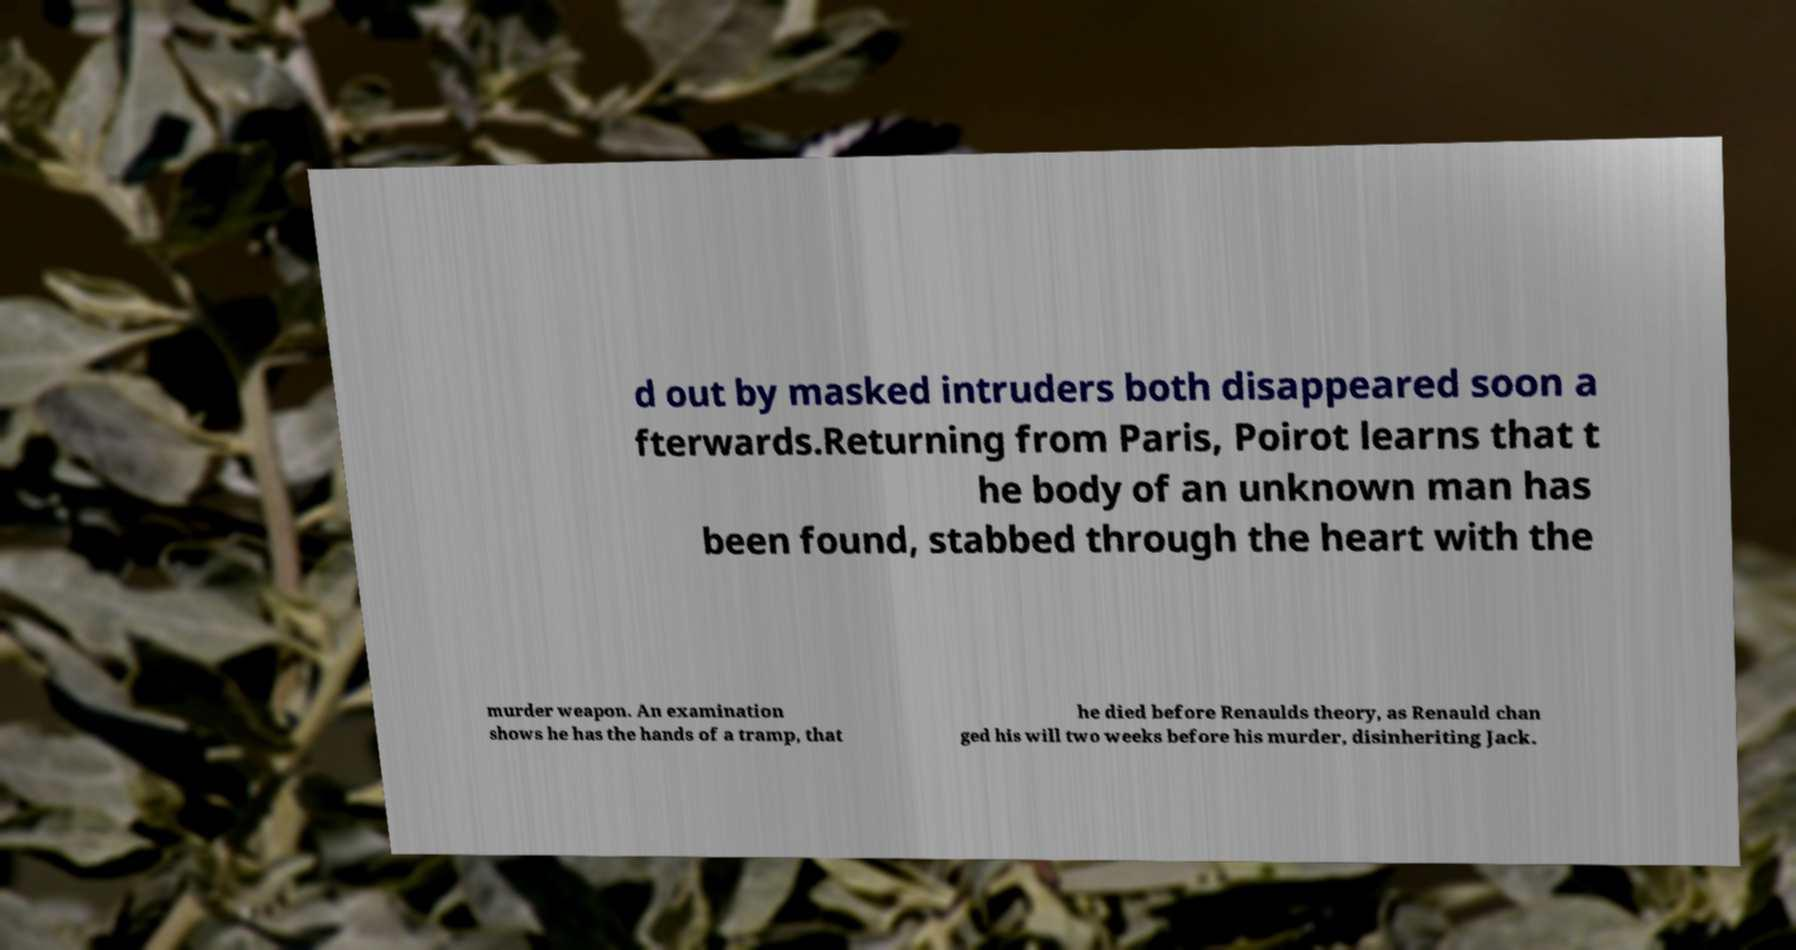What messages or text are displayed in this image? I need them in a readable, typed format. d out by masked intruders both disappeared soon a fterwards.Returning from Paris, Poirot learns that t he body of an unknown man has been found, stabbed through the heart with the murder weapon. An examination shows he has the hands of a tramp, that he died before Renaulds theory, as Renauld chan ged his will two weeks before his murder, disinheriting Jack. 